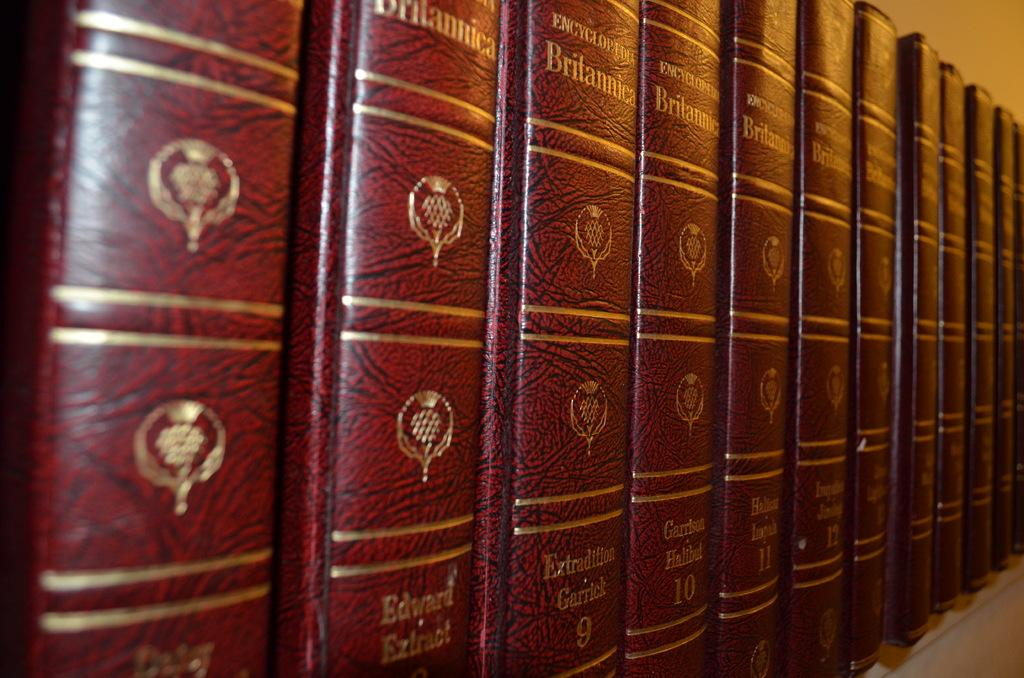Provide a one-sentence caption for the provided image. A set of red bound encyclopedia Britannicas lined up in a row. 